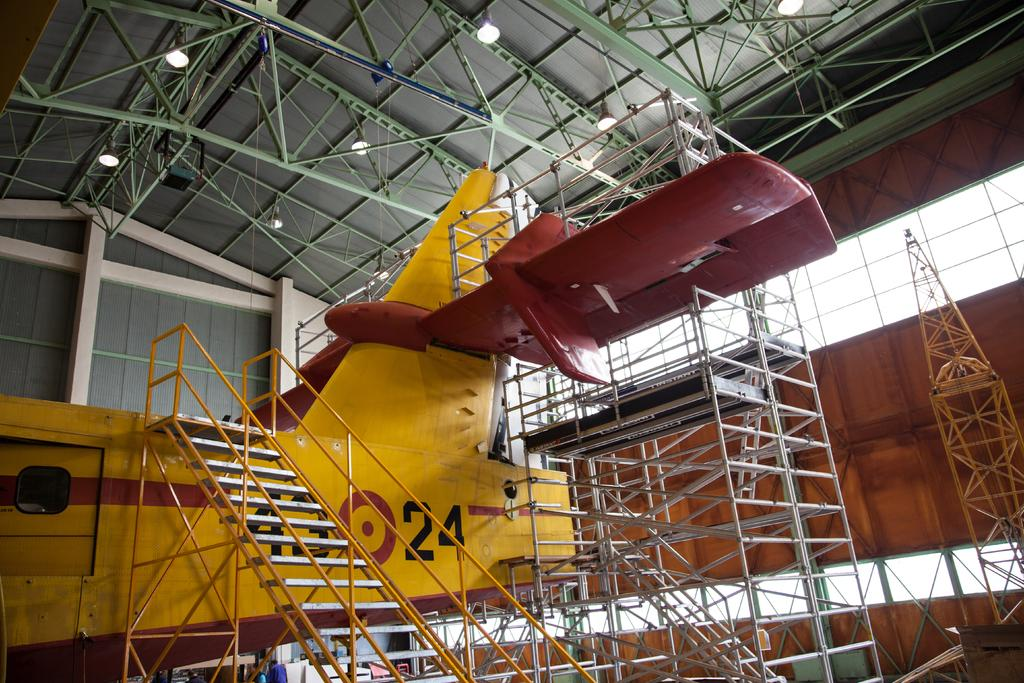<image>
Offer a succinct explanation of the picture presented. A yellow airplane has the number 24 painted on it in black. 